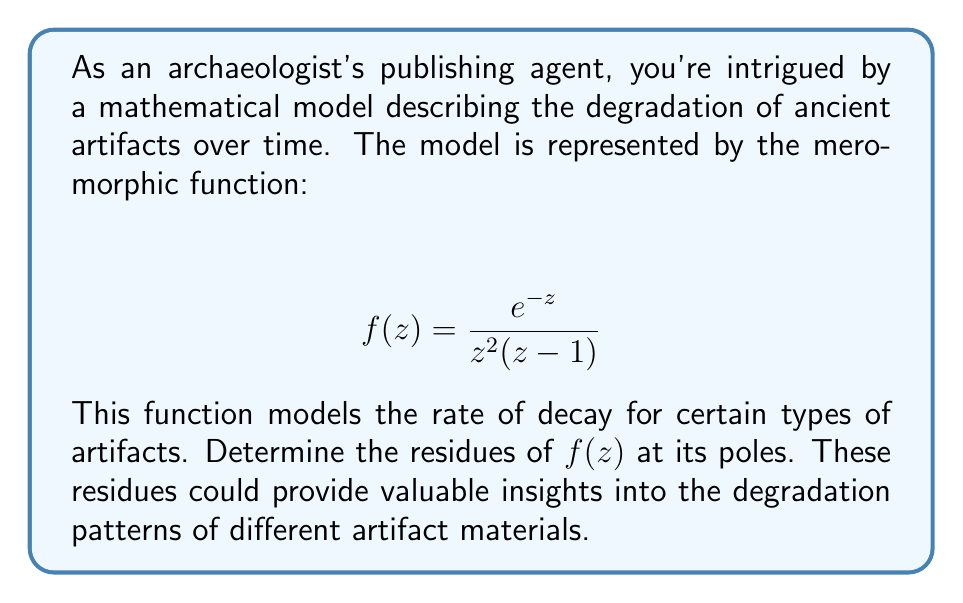Teach me how to tackle this problem. To find the residues of $f(z)$, we need to identify its poles and calculate the residue at each pole:

1) The poles of $f(z)$ are at $z=0$ (order 2) and $z=1$ (order 1).

2) For the double pole at $z=0$:
   We use the formula for the residue of a double pole:
   $$\text{Res}(f,0) = \lim_{z\to 0} \frac{d}{dz}\left[z^2f(z)\right]$$
   
   $$\begin{aligned}
   \text{Res}(f,0) &= \lim_{z\to 0} \frac{d}{dz}\left[\frac{e^{-z}}{z-1}\right] \\
   &= \lim_{z\to 0} \frac{-e^{-z}(z-1) - e^{-z}(-1)}{(z-1)^2} \\
   &= \frac{-e^0(-1) - e^0(-1)}{(-1)^2} = 2
   \end{aligned}$$

3) For the simple pole at $z=1$:
   We use the formula for the residue of a simple pole:
   $$\text{Res}(f,1) = \lim_{z\to 1} (z-1)f(z)$$
   
   $$\begin{aligned}
   \text{Res}(f,1) &= \lim_{z\to 1} (z-1)\frac{e^{-z}}{z^2(z-1)} \\
   &= \lim_{z\to 1} \frac{e^{-z}}{z^2} \\
   &= \frac{e^{-1}}{1^2} = e^{-1}
   \end{aligned}$$

Therefore, the residues are 2 at $z=0$ and $e^{-1}$ at $z=1$.
Answer: $\text{Res}(f,0) = 2$, $\text{Res}(f,1) = e^{-1}$ 